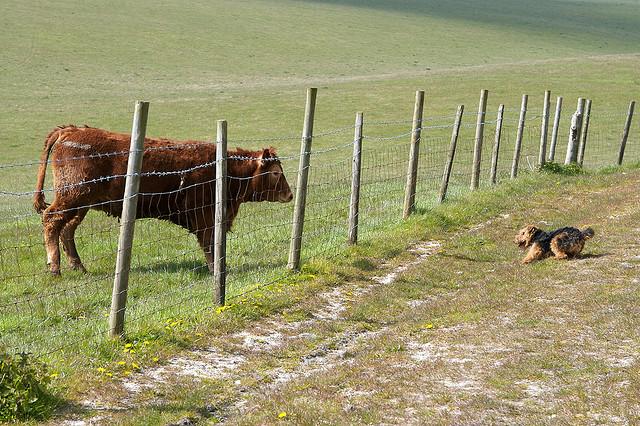What is the dog doing?
Short answer required. Barking. What animals are in this scene?
Answer briefly. Cow and dog. Is there a fence between the animals?
Short answer required. Yes. How many dogs?
Short answer required. 1. 